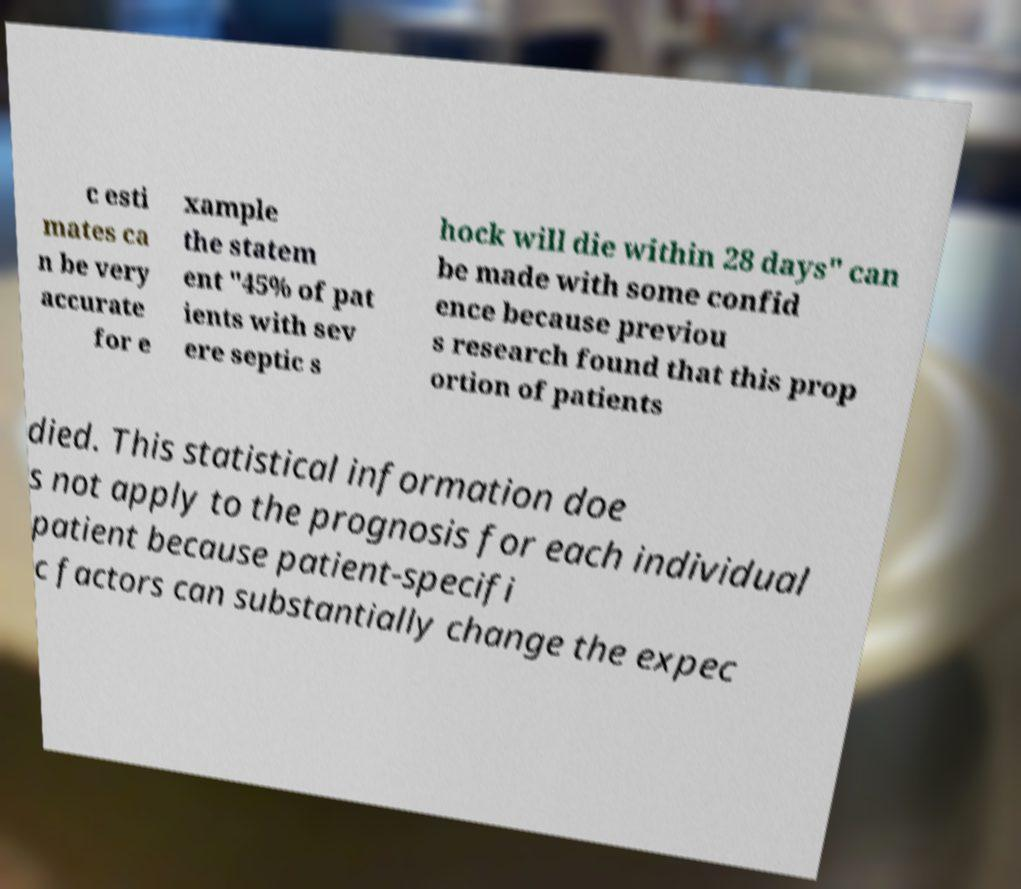There's text embedded in this image that I need extracted. Can you transcribe it verbatim? c esti mates ca n be very accurate for e xample the statem ent "45% of pat ients with sev ere septic s hock will die within 28 days" can be made with some confid ence because previou s research found that this prop ortion of patients died. This statistical information doe s not apply to the prognosis for each individual patient because patient-specifi c factors can substantially change the expec 